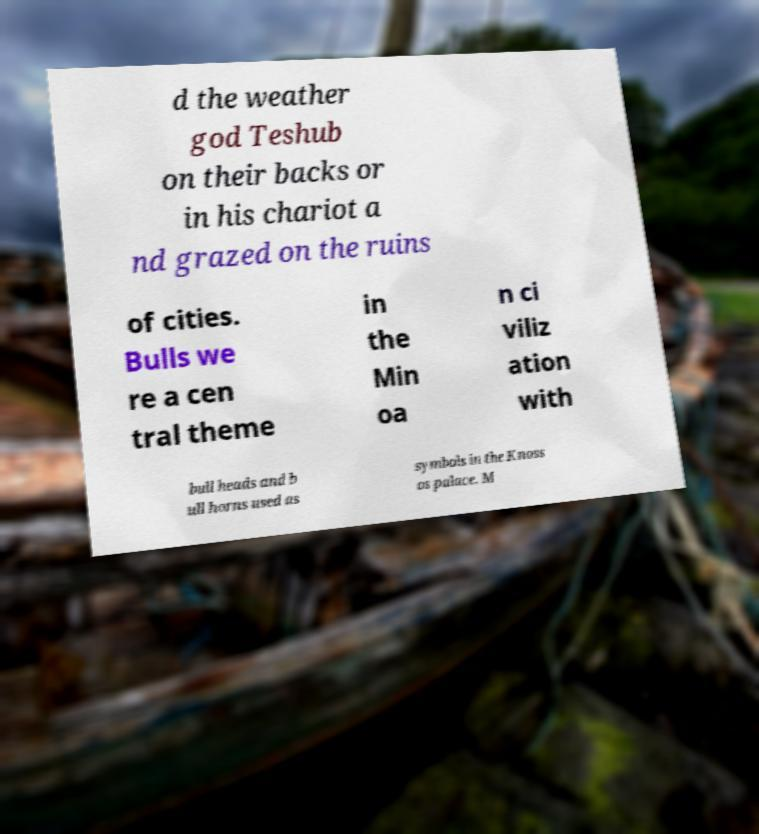Can you accurately transcribe the text from the provided image for me? d the weather god Teshub on their backs or in his chariot a nd grazed on the ruins of cities. Bulls we re a cen tral theme in the Min oa n ci viliz ation with bull heads and b ull horns used as symbols in the Knoss os palace. M 